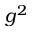<formula> <loc_0><loc_0><loc_500><loc_500>g ^ { 2 }</formula> 